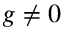Convert formula to latex. <formula><loc_0><loc_0><loc_500><loc_500>g \neq 0</formula> 